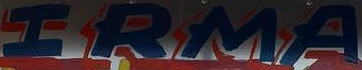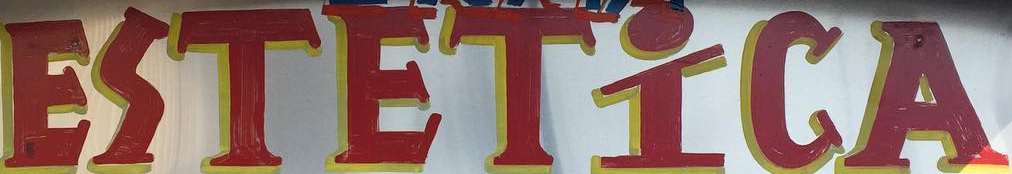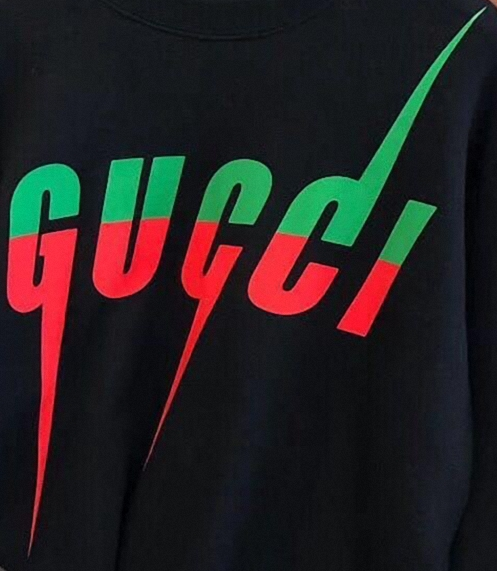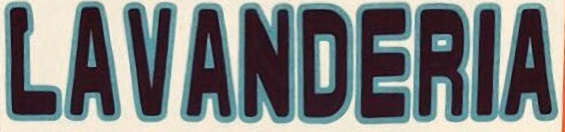What text appears in these images from left to right, separated by a semicolon? IRMA; ESTETİCA; GUCCI; LAVANDERIA 